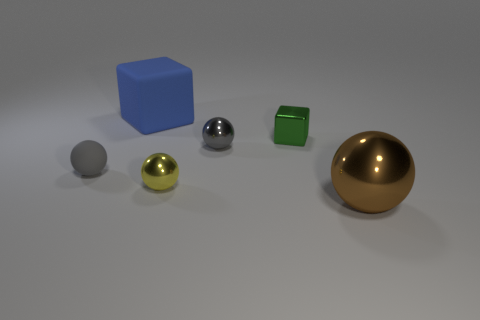Subtract all red cylinders. How many gray balls are left? 2 Subtract all big balls. How many balls are left? 3 Subtract 1 balls. How many balls are left? 3 Add 2 small purple matte things. How many objects exist? 8 Subtract all brown balls. How many balls are left? 3 Subtract all purple balls. Subtract all gray blocks. How many balls are left? 4 Subtract 0 blue balls. How many objects are left? 6 Subtract all spheres. How many objects are left? 2 Subtract all large brown rubber spheres. Subtract all small yellow spheres. How many objects are left? 5 Add 3 green blocks. How many green blocks are left? 4 